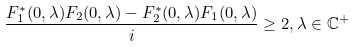Convert formula to latex. <formula><loc_0><loc_0><loc_500><loc_500>\frac { F _ { 1 } ^ { \ast } ( 0 , \lambda ) F _ { 2 } ( 0 , \lambda ) - F _ { 2 } ^ { \ast } ( 0 , \lambda ) F _ { 1 } ( 0 , \lambda ) } { i } \geq 2 , \lambda \in \mathbb { C } ^ { + }</formula> 